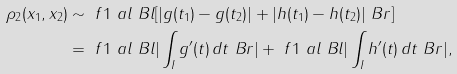Convert formula to latex. <formula><loc_0><loc_0><loc_500><loc_500>\rho _ { 2 } ( x _ { 1 } , x _ { 2 } ) & \sim \ f 1 \ a l \ B l [ | g ( t _ { 1 } ) - g ( t _ { 2 } ) | + | h ( t _ { 1 } ) - h ( t _ { 2 } ) | \ B r ] \\ & = \ f 1 \ a l \ B l | \int _ { I } g ^ { \prime } ( t ) \, d t \ B r | + \ f 1 \ a l \ B l | \int _ { I } h ^ { \prime } ( t ) \, d t \ B r | ,</formula> 